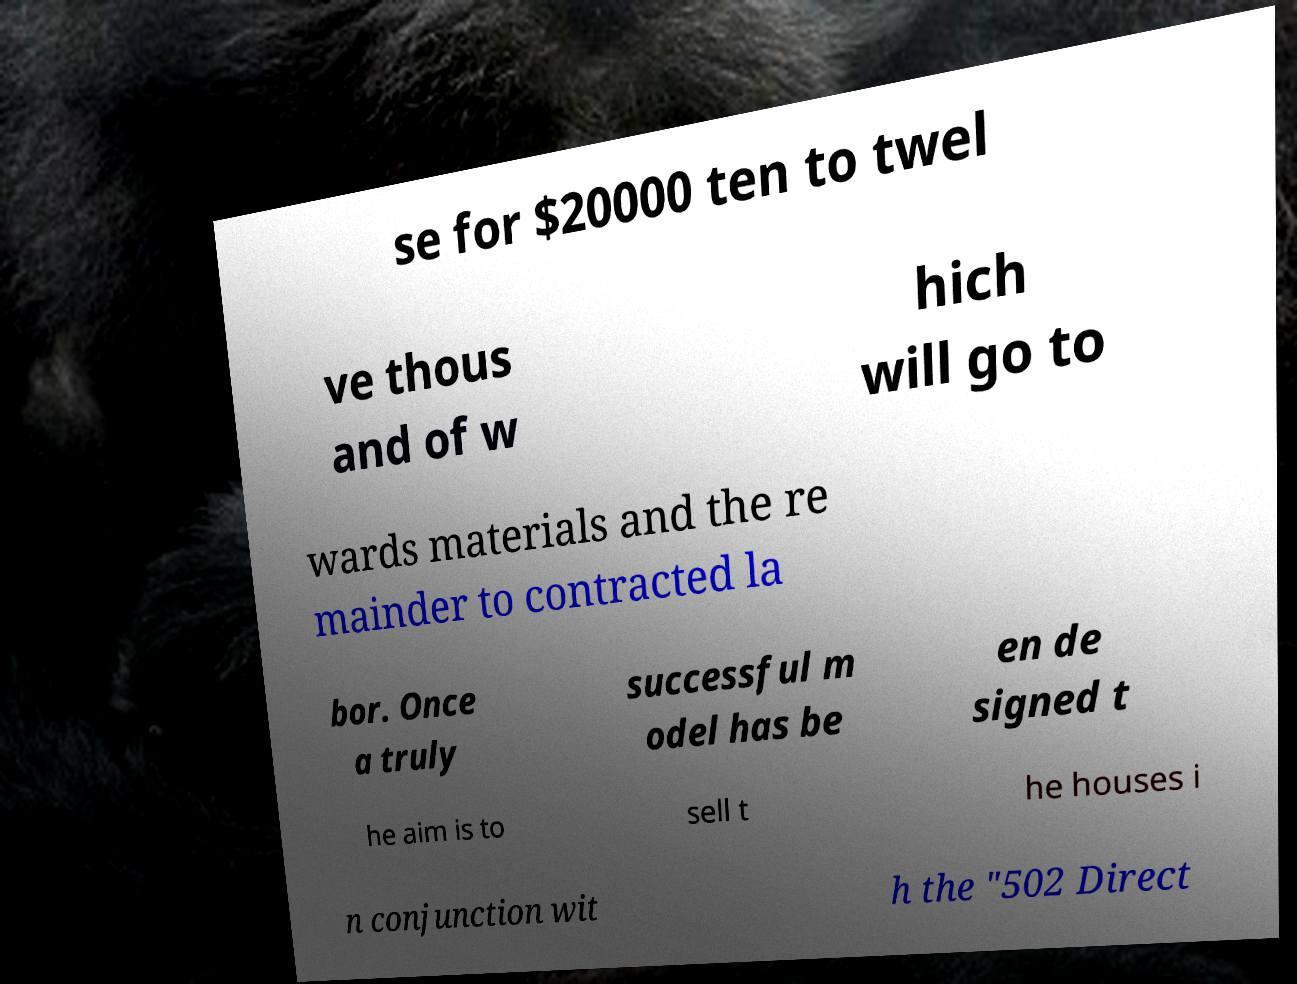Please identify and transcribe the text found in this image. se for $20000 ten to twel ve thous and of w hich will go to wards materials and the re mainder to contracted la bor. Once a truly successful m odel has be en de signed t he aim is to sell t he houses i n conjunction wit h the "502 Direct 